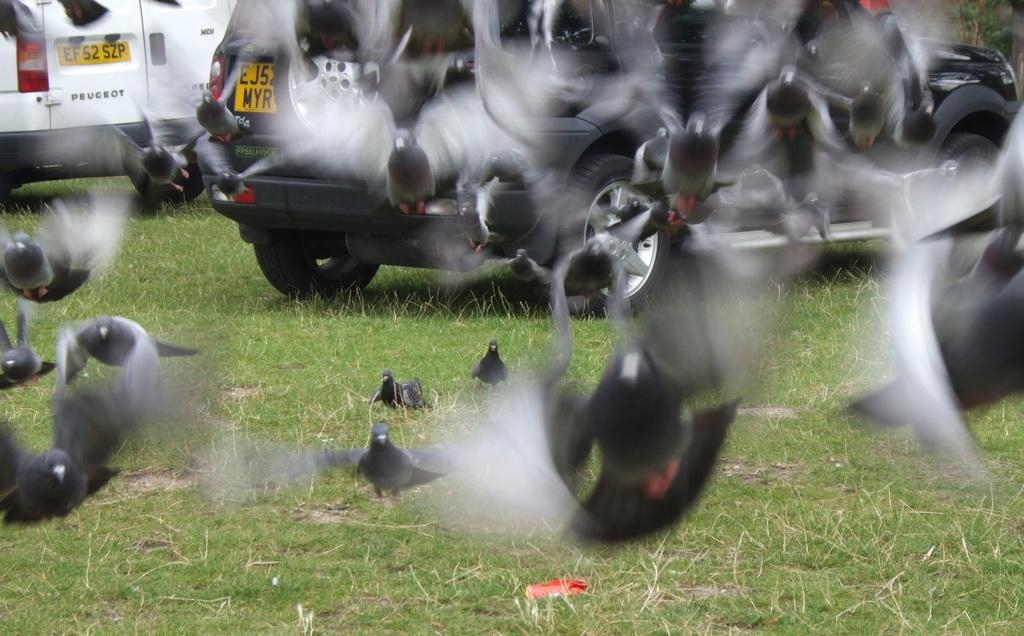What type of vegetation can be seen in the image? There is grass in the image. What animals are present in the image? There are birds in the image. What can be seen in the distance in the image? There are vehicles visible in the background of the image. How many pickles are on the grass in the image? There are no pickles present in the image; it features grass and birds. What type of eggs can be seen in the image? There are no eggs present in the image. 